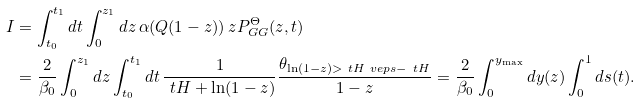<formula> <loc_0><loc_0><loc_500><loc_500>I & = \int _ { t _ { 0 } } ^ { t _ { 1 } } d t \int _ { 0 } ^ { z _ { 1 } } d z \, \alpha ( Q ( 1 - z ) ) \, z P ^ { \Theta } _ { G G } ( z , t ) \\ & = \frac { 2 } { \beta _ { 0 } } \int _ { 0 } ^ { z _ { 1 } } d z \int _ { t _ { 0 } } ^ { t _ { 1 } } d t \, \frac { 1 } { \ t H + \ln ( 1 - z ) } \frac { \theta _ { \ln ( 1 - z ) > \ t H _ { \ } v e p s - \ t H } } { 1 - z } = \frac { 2 } { \beta _ { 0 } } \int _ { 0 } ^ { y _ { \max } } d y ( z ) \int _ { 0 } ^ { 1 } d s ( t ) .</formula> 